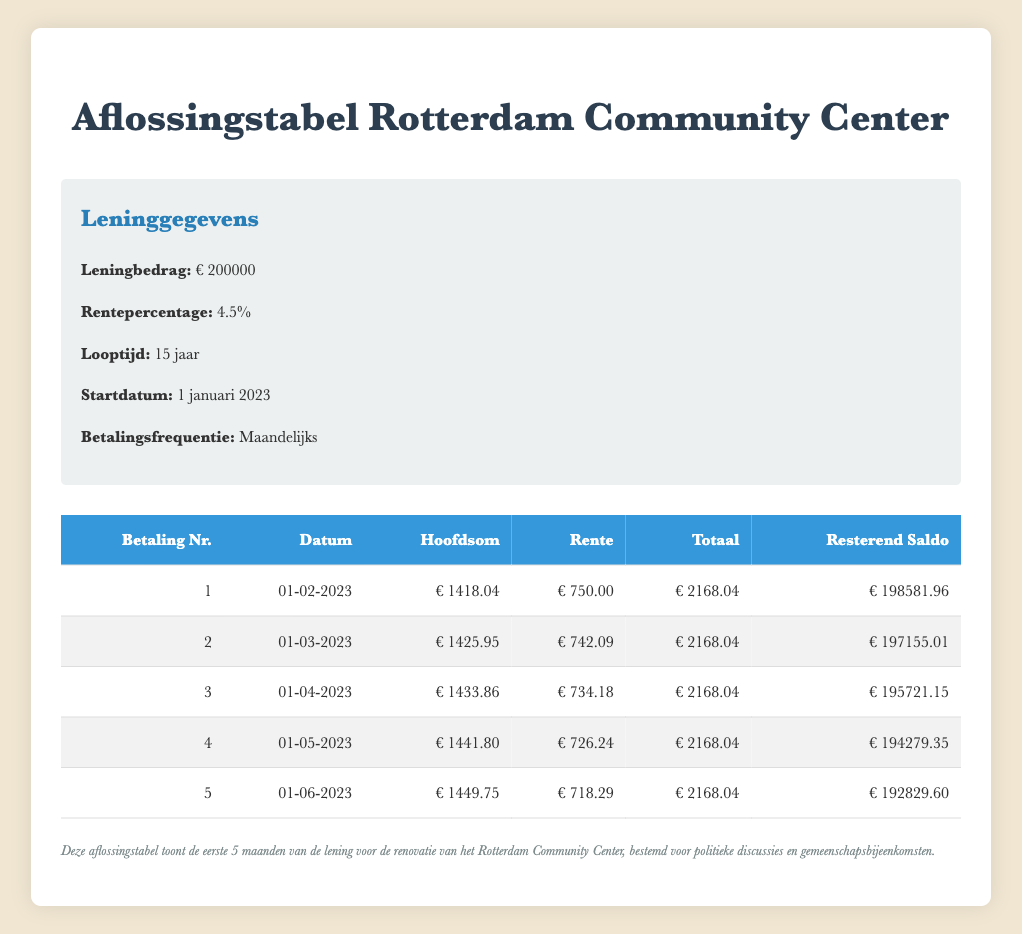What is the total payment for the first month? The first month's total payment is visible in the table under the "Totaal" column for payment number 1, which reads €2168.04.
Answer: €2168.04 What is the interest payment in the second month? The second month's interest payment can be found in the table under the "Rente" column for payment number 2, which shows €742.09.
Answer: €742.09 How much principal is paid off by the fifth month? To find the total principal paid off by the fifth month, add the "Hoofdsom" payments from payment numbers 1 to 5: 1418.04 + 1425.95 + 1433.86 + 1441.80 + 1449.75 = 7169.40.
Answer: €7169.40 Is the interest payment in the first month greater than in the subsequent months? Comparing the "Rente" values, the first month's payment of €750.00 is indeed greater than the second (€742.09), third (€734.18), fourth (€726.24), and fifth (€718.29) months, confirming that the first month has the highest interest payment.
Answer: Yes What is the remaining balance after the third month? The remaining balance after the third month can be located in the "Resterend Saldo" column for payment number 3, which shows €195721.15.
Answer: €195721.15 What is the average principal payment over the first five months? To calculate the average principal payment, sum the principal payments for the first five months: 1418.04 + 1425.95 + 1433.86 + 1441.80 + 1449.75 = 7169.40, then divide by 5: 7169.40 / 5 = 1433.88.
Answer: €1433.88 How does the total payment in the fourth month compare to the first month? The total payment for the fourth month is €2168.04 and is the same as the first month's total payment, indicating consistency in total payments across these two months.
Answer: Same What is the difference in total payment between the third and fourth months? The total payments for both months are €2168.04, so the difference is €2168.04 - €2168.04 = 0.
Answer: 0 